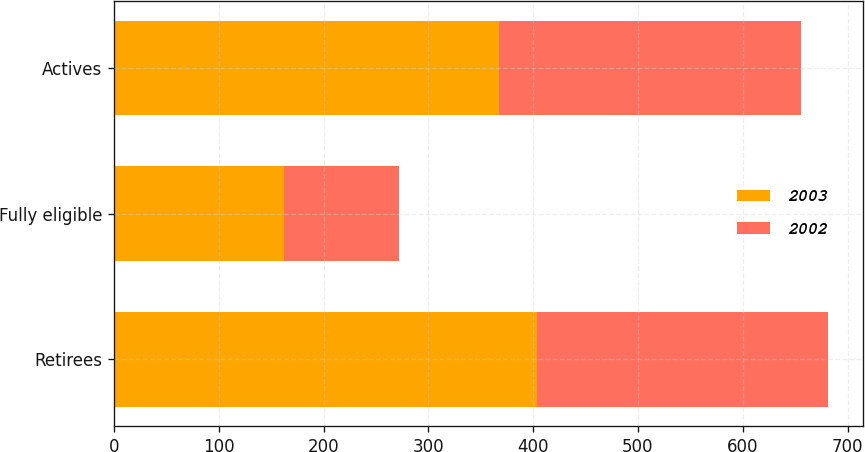Convert chart. <chart><loc_0><loc_0><loc_500><loc_500><stacked_bar_chart><ecel><fcel>Retirees<fcel>Fully eligible<fcel>Actives<nl><fcel>2003<fcel>404<fcel>162<fcel>367<nl><fcel>2002<fcel>277<fcel>110<fcel>289<nl></chart> 